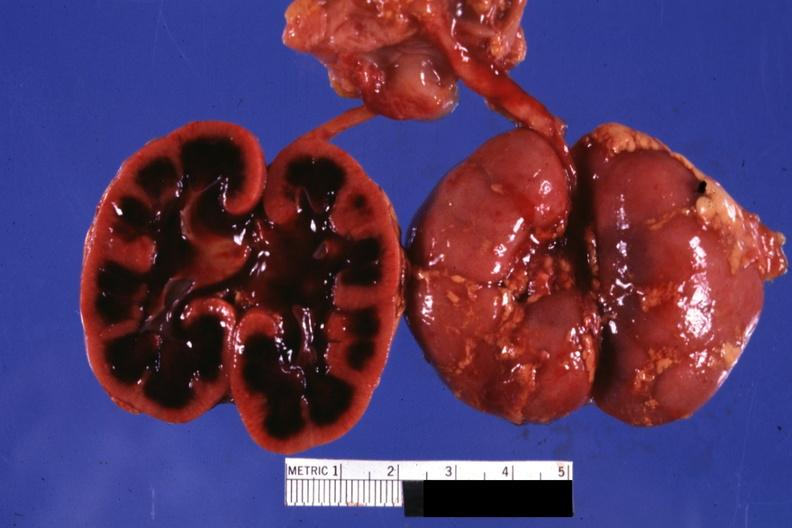s ischemia infant present?
Answer the question using a single word or phrase. Yes 